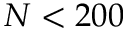<formula> <loc_0><loc_0><loc_500><loc_500>N < 2 0 0</formula> 